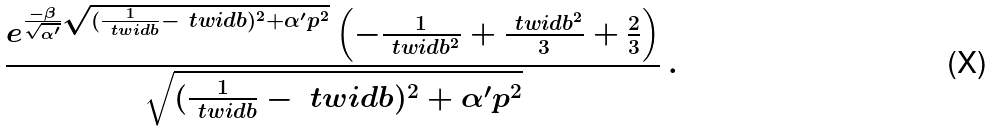Convert formula to latex. <formula><loc_0><loc_0><loc_500><loc_500>\frac { e ^ { \frac { - \beta } { \sqrt { \alpha ^ { \prime } } } \sqrt { ( \frac { 1 } { \ t w i d { b } } - \ t w i d { b } ) ^ { 2 } + \alpha ^ { \prime } p ^ { 2 } } } \left ( - \frac { 1 } { \ t w i d { b } ^ { 2 } } + \frac { \ t w i d { b } ^ { 2 } } { 3 } + \frac { 2 } { 3 } \right ) } { \sqrt { ( \frac { 1 } { \ t w i d { b } } - \ t w i d { b } ) ^ { 2 } + \alpha ^ { \prime } p ^ { 2 } } } \, .</formula> 